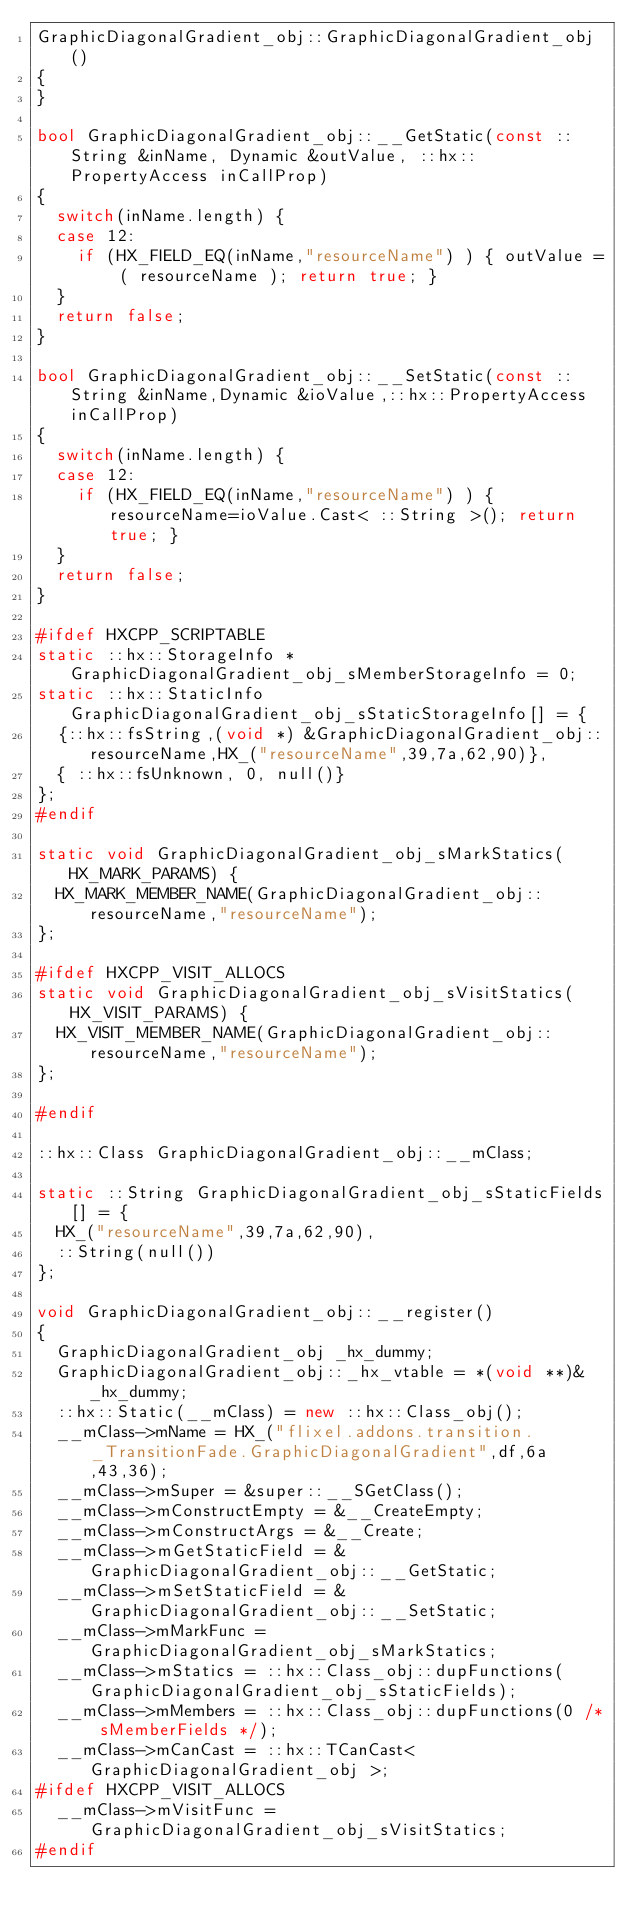Convert code to text. <code><loc_0><loc_0><loc_500><loc_500><_C++_>GraphicDiagonalGradient_obj::GraphicDiagonalGradient_obj()
{
}

bool GraphicDiagonalGradient_obj::__GetStatic(const ::String &inName, Dynamic &outValue, ::hx::PropertyAccess inCallProp)
{
	switch(inName.length) {
	case 12:
		if (HX_FIELD_EQ(inName,"resourceName") ) { outValue = ( resourceName ); return true; }
	}
	return false;
}

bool GraphicDiagonalGradient_obj::__SetStatic(const ::String &inName,Dynamic &ioValue,::hx::PropertyAccess inCallProp)
{
	switch(inName.length) {
	case 12:
		if (HX_FIELD_EQ(inName,"resourceName") ) { resourceName=ioValue.Cast< ::String >(); return true; }
	}
	return false;
}

#ifdef HXCPP_SCRIPTABLE
static ::hx::StorageInfo *GraphicDiagonalGradient_obj_sMemberStorageInfo = 0;
static ::hx::StaticInfo GraphicDiagonalGradient_obj_sStaticStorageInfo[] = {
	{::hx::fsString,(void *) &GraphicDiagonalGradient_obj::resourceName,HX_("resourceName",39,7a,62,90)},
	{ ::hx::fsUnknown, 0, null()}
};
#endif

static void GraphicDiagonalGradient_obj_sMarkStatics(HX_MARK_PARAMS) {
	HX_MARK_MEMBER_NAME(GraphicDiagonalGradient_obj::resourceName,"resourceName");
};

#ifdef HXCPP_VISIT_ALLOCS
static void GraphicDiagonalGradient_obj_sVisitStatics(HX_VISIT_PARAMS) {
	HX_VISIT_MEMBER_NAME(GraphicDiagonalGradient_obj::resourceName,"resourceName");
};

#endif

::hx::Class GraphicDiagonalGradient_obj::__mClass;

static ::String GraphicDiagonalGradient_obj_sStaticFields[] = {
	HX_("resourceName",39,7a,62,90),
	::String(null())
};

void GraphicDiagonalGradient_obj::__register()
{
	GraphicDiagonalGradient_obj _hx_dummy;
	GraphicDiagonalGradient_obj::_hx_vtable = *(void **)&_hx_dummy;
	::hx::Static(__mClass) = new ::hx::Class_obj();
	__mClass->mName = HX_("flixel.addons.transition._TransitionFade.GraphicDiagonalGradient",df,6a,43,36);
	__mClass->mSuper = &super::__SGetClass();
	__mClass->mConstructEmpty = &__CreateEmpty;
	__mClass->mConstructArgs = &__Create;
	__mClass->mGetStaticField = &GraphicDiagonalGradient_obj::__GetStatic;
	__mClass->mSetStaticField = &GraphicDiagonalGradient_obj::__SetStatic;
	__mClass->mMarkFunc = GraphicDiagonalGradient_obj_sMarkStatics;
	__mClass->mStatics = ::hx::Class_obj::dupFunctions(GraphicDiagonalGradient_obj_sStaticFields);
	__mClass->mMembers = ::hx::Class_obj::dupFunctions(0 /* sMemberFields */);
	__mClass->mCanCast = ::hx::TCanCast< GraphicDiagonalGradient_obj >;
#ifdef HXCPP_VISIT_ALLOCS
	__mClass->mVisitFunc = GraphicDiagonalGradient_obj_sVisitStatics;
#endif</code> 